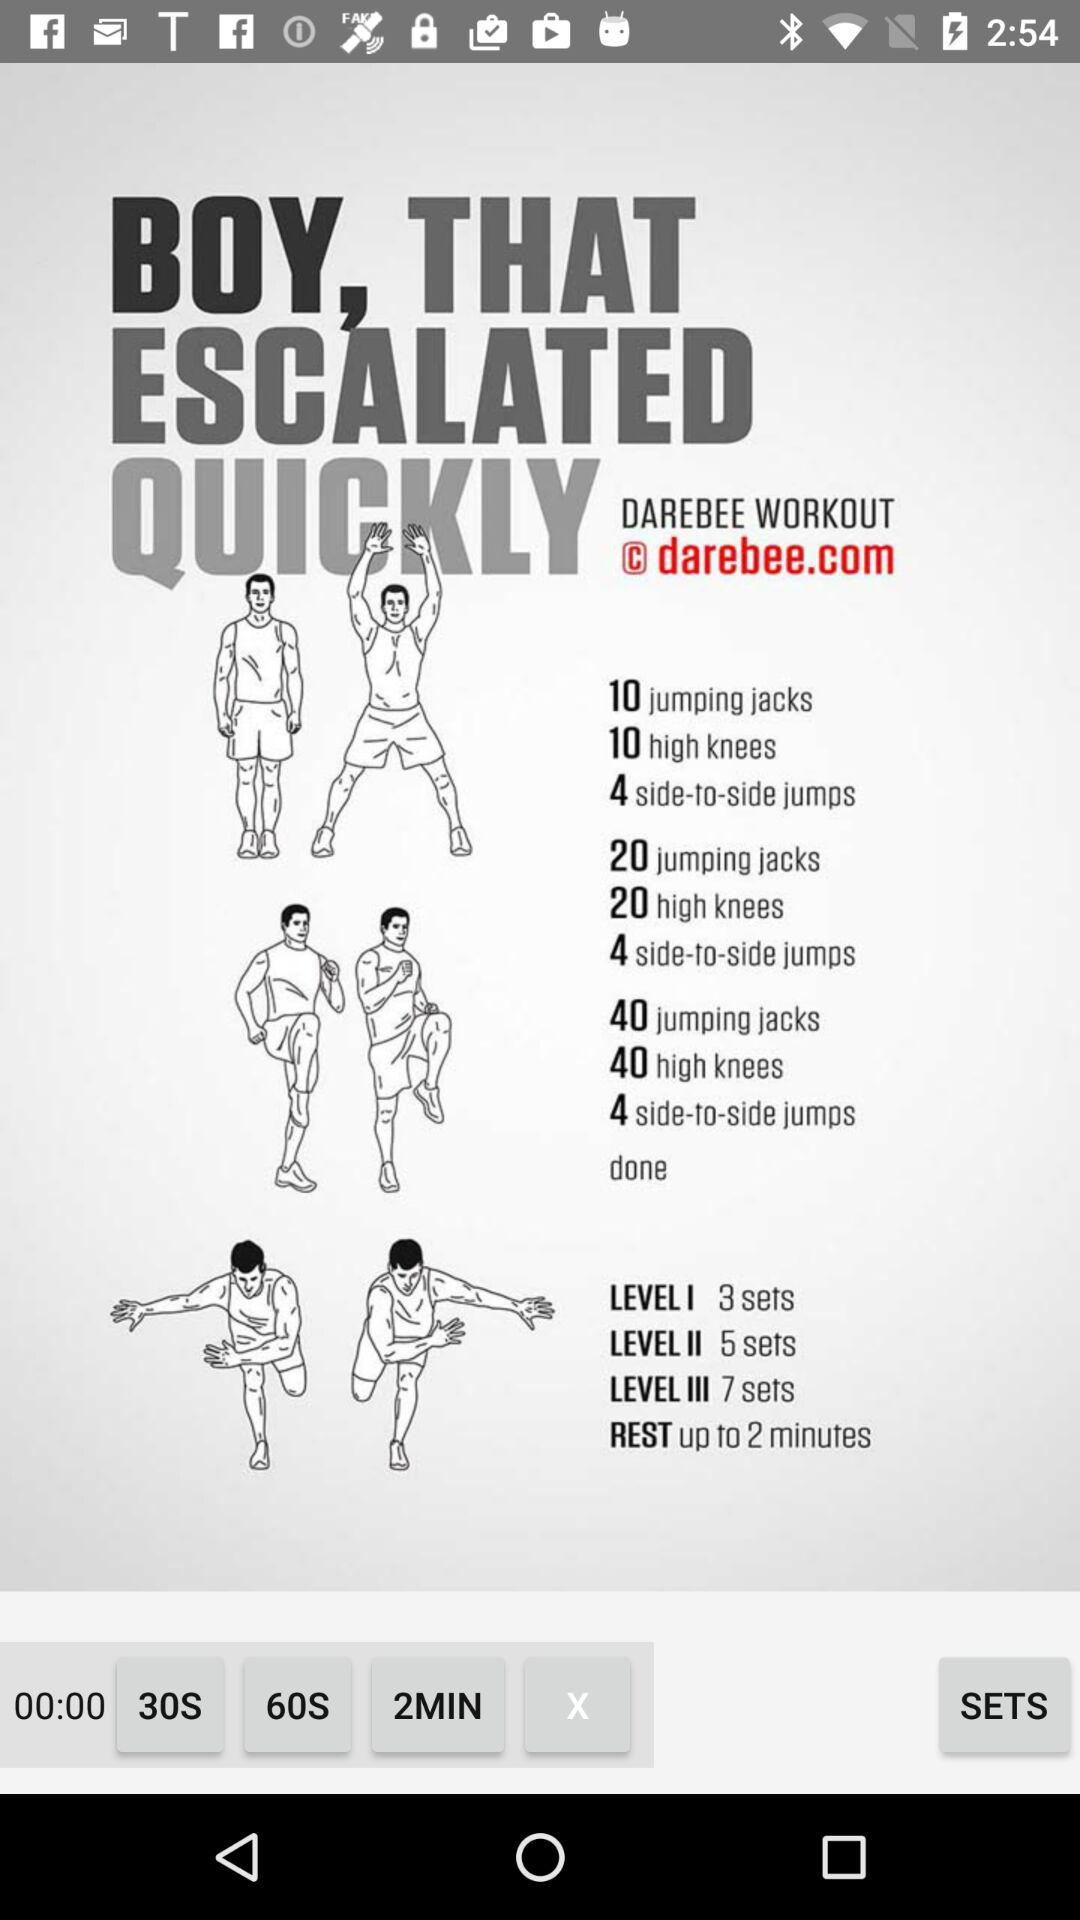How many sets does Level 2 include? Level 2 includes 5 sets. 